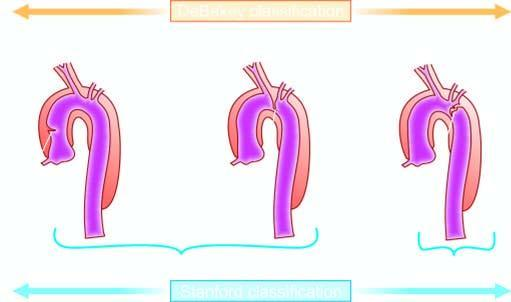s stanford type b limited to descending aorta?
Answer the question using a single word or phrase. Yes 